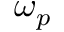Convert formula to latex. <formula><loc_0><loc_0><loc_500><loc_500>\omega _ { p }</formula> 